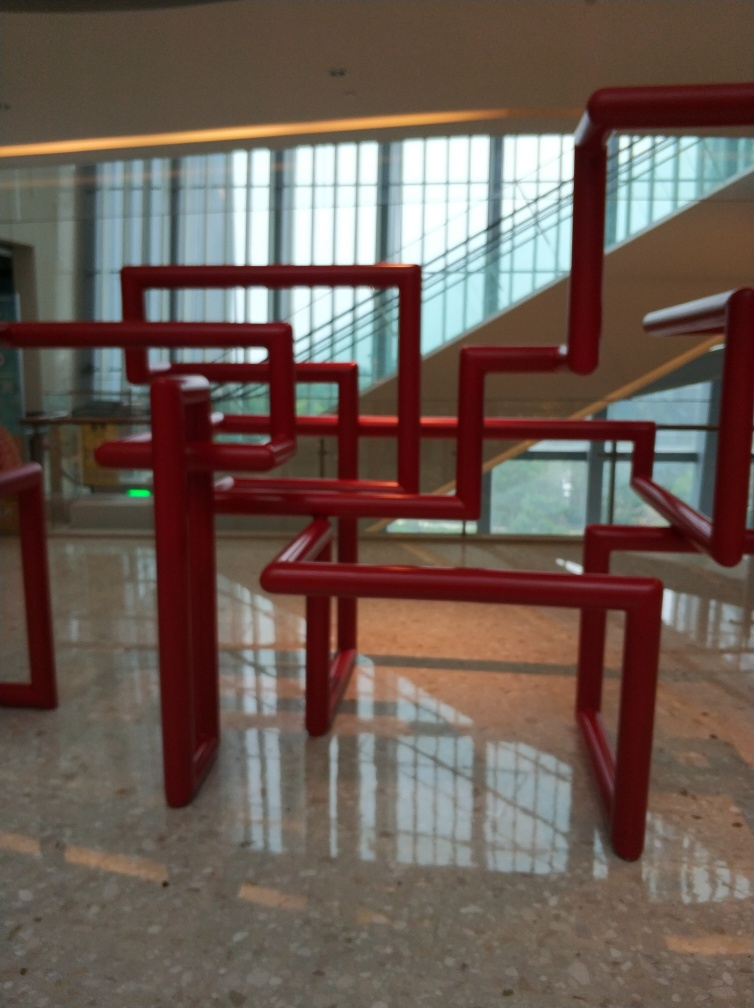How does the reflection on the floor contribute to the overall visual impact of the scene? The reflections on the glossy floor enhance the visual interest of the scene, creating a symmetrical effect that doubles the complexity of the structures. It adds depth and a layer of intrigue as viewers might ponder the interplay between the tangible structures and their mirrored counterparts. 